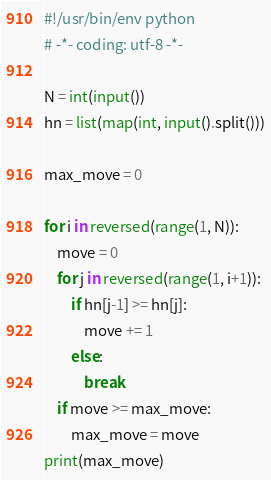<code> <loc_0><loc_0><loc_500><loc_500><_Python_>#!/usr/bin/env python
# -*- coding: utf-8 -*-

N = int(input())
hn = list(map(int, input().split()))

max_move = 0

for i in reversed(range(1, N)):
    move = 0
    for j in reversed(range(1, i+1)):
        if hn[j-1] >= hn[j]:
            move += 1
        else:
            break
    if move >= max_move:
        max_move = move
print(max_move)
</code> 